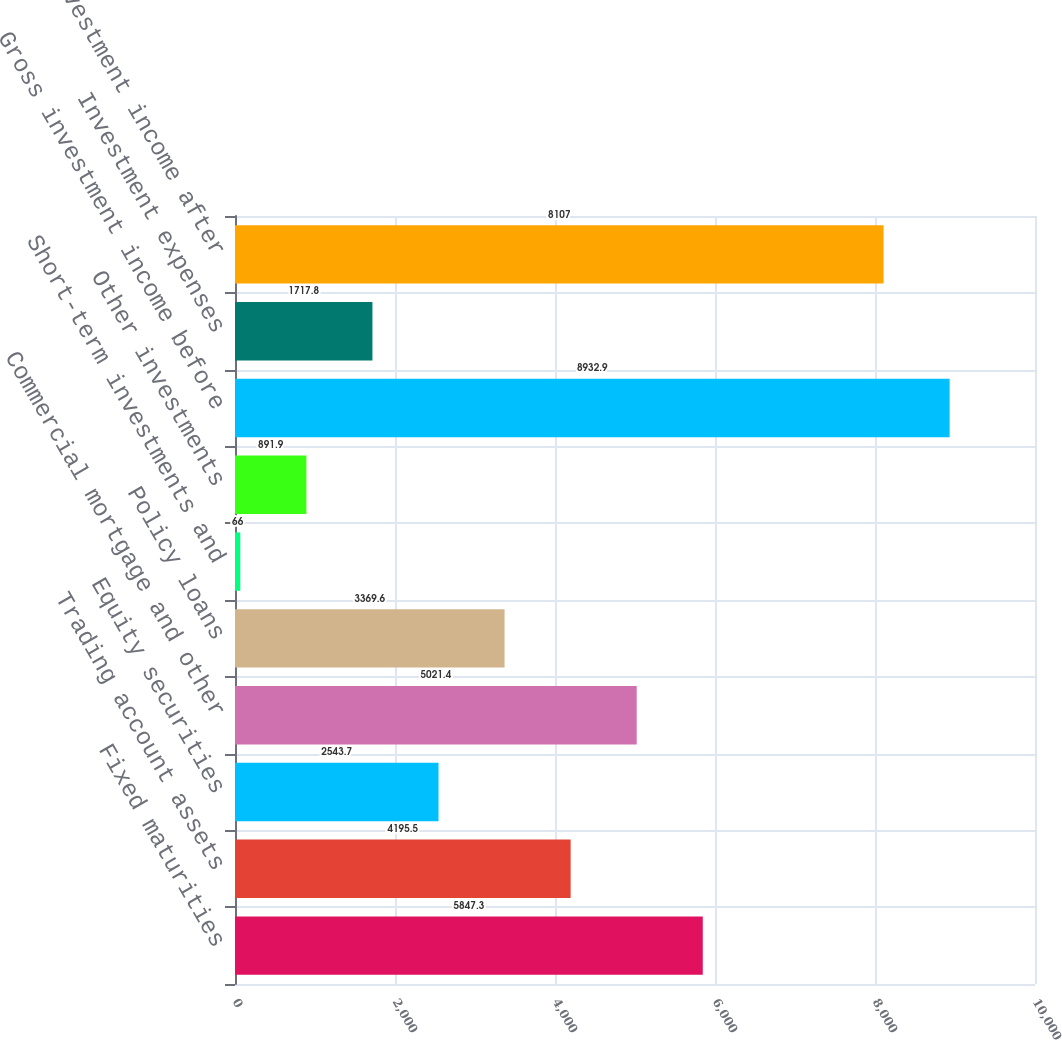Convert chart. <chart><loc_0><loc_0><loc_500><loc_500><bar_chart><fcel>Fixed maturities<fcel>Trading account assets<fcel>Equity securities<fcel>Commercial mortgage and other<fcel>Policy loans<fcel>Short-term investments and<fcel>Other investments<fcel>Gross investment income before<fcel>Investment expenses<fcel>Investment income after<nl><fcel>5847.3<fcel>4195.5<fcel>2543.7<fcel>5021.4<fcel>3369.6<fcel>66<fcel>891.9<fcel>8932.9<fcel>1717.8<fcel>8107<nl></chart> 